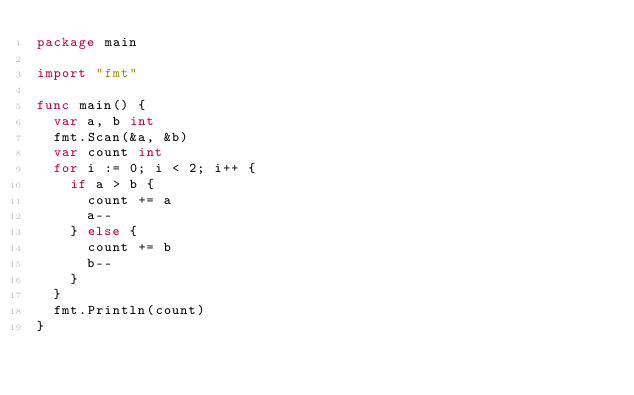<code> <loc_0><loc_0><loc_500><loc_500><_Go_>package main

import "fmt"

func main() {
  var a, b int
  fmt.Scan(&a, &b)
  var count int
  for i := 0; i < 2; i++ {
    if a > b {
      count += a
      a--
    } else {
      count += b
      b--
    }
  }
  fmt.Println(count)
}</code> 